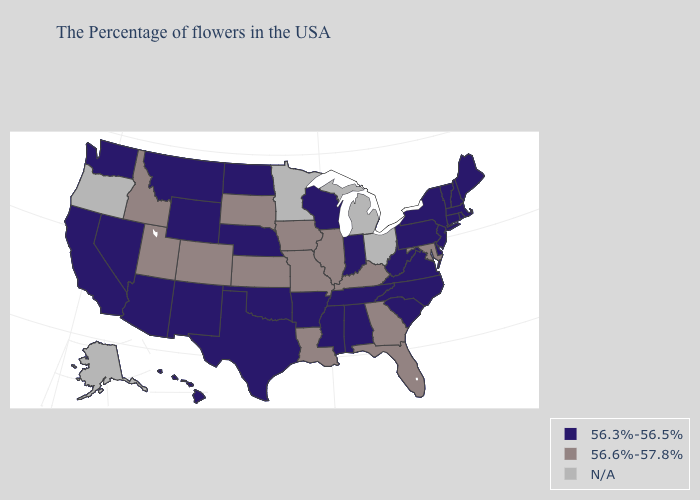Name the states that have a value in the range 56.3%-56.5%?
Answer briefly. Maine, Massachusetts, Rhode Island, New Hampshire, Vermont, Connecticut, New York, New Jersey, Delaware, Pennsylvania, Virginia, North Carolina, South Carolina, West Virginia, Indiana, Alabama, Tennessee, Wisconsin, Mississippi, Arkansas, Nebraska, Oklahoma, Texas, North Dakota, Wyoming, New Mexico, Montana, Arizona, Nevada, California, Washington, Hawaii. Which states have the lowest value in the Northeast?
Short answer required. Maine, Massachusetts, Rhode Island, New Hampshire, Vermont, Connecticut, New York, New Jersey, Pennsylvania. Name the states that have a value in the range 56.3%-56.5%?
Quick response, please. Maine, Massachusetts, Rhode Island, New Hampshire, Vermont, Connecticut, New York, New Jersey, Delaware, Pennsylvania, Virginia, North Carolina, South Carolina, West Virginia, Indiana, Alabama, Tennessee, Wisconsin, Mississippi, Arkansas, Nebraska, Oklahoma, Texas, North Dakota, Wyoming, New Mexico, Montana, Arizona, Nevada, California, Washington, Hawaii. Does New Hampshire have the highest value in the USA?
Concise answer only. No. What is the highest value in the USA?
Quick response, please. 56.6%-57.8%. What is the lowest value in states that border Kentucky?
Give a very brief answer. 56.3%-56.5%. Does Utah have the highest value in the USA?
Concise answer only. Yes. Does Nevada have the highest value in the USA?
Answer briefly. No. Name the states that have a value in the range 56.6%-57.8%?
Short answer required. Maryland, Florida, Georgia, Kentucky, Illinois, Louisiana, Missouri, Iowa, Kansas, South Dakota, Colorado, Utah, Idaho. Name the states that have a value in the range N/A?
Keep it brief. Ohio, Michigan, Minnesota, Oregon, Alaska. Which states have the lowest value in the USA?
Concise answer only. Maine, Massachusetts, Rhode Island, New Hampshire, Vermont, Connecticut, New York, New Jersey, Delaware, Pennsylvania, Virginia, North Carolina, South Carolina, West Virginia, Indiana, Alabama, Tennessee, Wisconsin, Mississippi, Arkansas, Nebraska, Oklahoma, Texas, North Dakota, Wyoming, New Mexico, Montana, Arizona, Nevada, California, Washington, Hawaii. Which states hav the highest value in the MidWest?
Quick response, please. Illinois, Missouri, Iowa, Kansas, South Dakota. What is the value of Utah?
Give a very brief answer. 56.6%-57.8%. What is the highest value in the Northeast ?
Answer briefly. 56.3%-56.5%. 